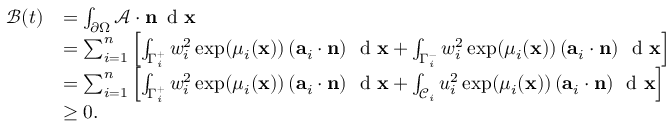Convert formula to latex. <formula><loc_0><loc_0><loc_500><loc_500>\begin{array} { r l } { \mathcal { B } ( t ) } & { = \int _ { \partial \Omega } \mathcal { A } \cdot n \, d x } \\ & { = \sum _ { i = 1 } ^ { n } \left [ \int _ { \Gamma _ { i } ^ { + } } w _ { i } ^ { 2 } \exp ( \mu _ { i } ( x ) ) \left ( a _ { i } \cdot n \right ) \, d x + \int _ { \Gamma _ { i } ^ { - } } w _ { i } ^ { 2 } \exp ( \mu _ { i } ( x ) ) \left ( a _ { i } \cdot n \right ) \, d x \right ] } \\ & { = \sum _ { i = 1 } ^ { n } \left [ \int _ { \Gamma _ { i } ^ { + } } w _ { i } ^ { 2 } \exp ( \mu _ { i } ( x ) ) \left ( a _ { i } \cdot n \right ) \, d x + \int _ { \mathcal { C } _ { i } } u _ { i } ^ { 2 } \exp ( \mu _ { i } ( x ) ) \left ( a _ { i } \cdot n \right ) \, d x \right ] } \\ & { \geq 0 . } \end{array}</formula> 